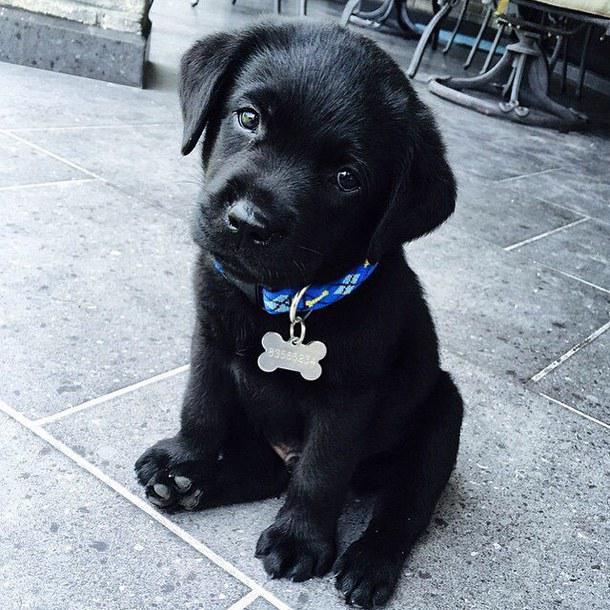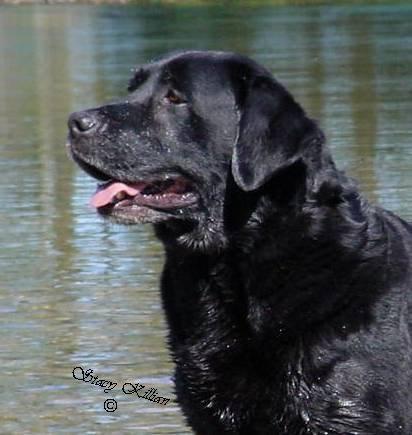The first image is the image on the left, the second image is the image on the right. For the images shown, is this caption "A large brown colored dog is outside." true? Answer yes or no. No. The first image is the image on the left, the second image is the image on the right. Analyze the images presented: Is the assertion "One of the images shows a black labrador and the other shows a brown labrador." valid? Answer yes or no. No. 